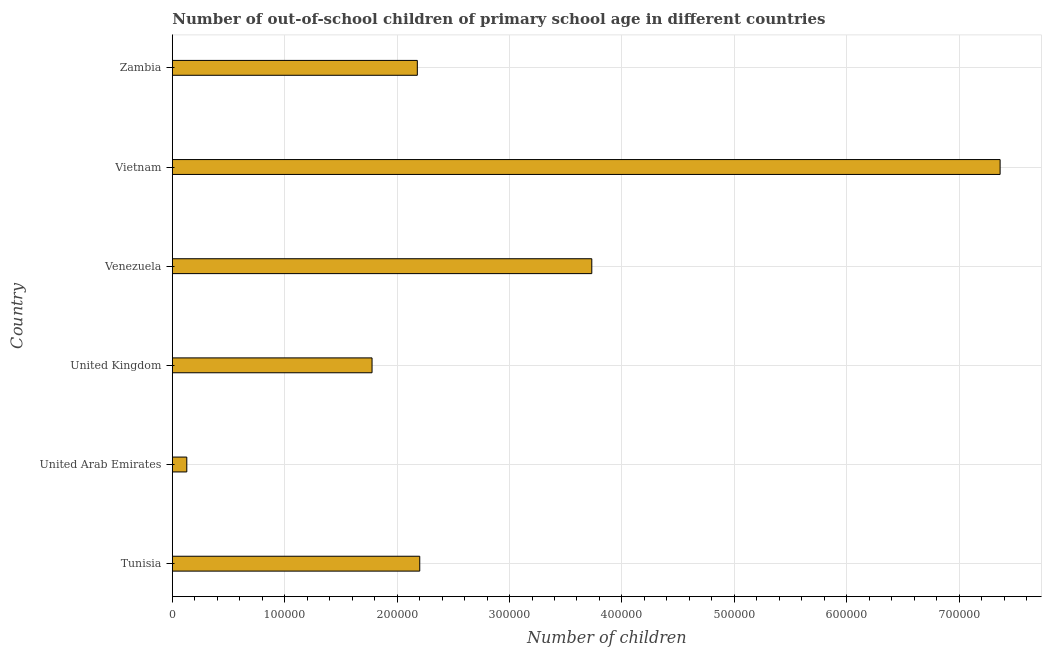Does the graph contain any zero values?
Give a very brief answer. No. Does the graph contain grids?
Your response must be concise. Yes. What is the title of the graph?
Your answer should be compact. Number of out-of-school children of primary school age in different countries. What is the label or title of the X-axis?
Your answer should be very brief. Number of children. What is the number of out-of-school children in Vietnam?
Provide a short and direct response. 7.36e+05. Across all countries, what is the maximum number of out-of-school children?
Make the answer very short. 7.36e+05. Across all countries, what is the minimum number of out-of-school children?
Your response must be concise. 1.29e+04. In which country was the number of out-of-school children maximum?
Offer a very short reply. Vietnam. In which country was the number of out-of-school children minimum?
Give a very brief answer. United Arab Emirates. What is the sum of the number of out-of-school children?
Offer a very short reply. 1.74e+06. What is the difference between the number of out-of-school children in Venezuela and Vietnam?
Offer a very short reply. -3.63e+05. What is the average number of out-of-school children per country?
Ensure brevity in your answer.  2.90e+05. What is the median number of out-of-school children?
Keep it short and to the point. 2.19e+05. In how many countries, is the number of out-of-school children greater than 120000 ?
Make the answer very short. 5. What is the ratio of the number of out-of-school children in Tunisia to that in Zambia?
Offer a terse response. 1.01. What is the difference between the highest and the second highest number of out-of-school children?
Your answer should be compact. 3.63e+05. Is the sum of the number of out-of-school children in United Arab Emirates and Vietnam greater than the maximum number of out-of-school children across all countries?
Provide a succinct answer. Yes. What is the difference between the highest and the lowest number of out-of-school children?
Provide a succinct answer. 7.24e+05. How many bars are there?
Make the answer very short. 6. How many countries are there in the graph?
Provide a succinct answer. 6. What is the difference between two consecutive major ticks on the X-axis?
Your answer should be compact. 1.00e+05. What is the Number of children in Tunisia?
Offer a very short reply. 2.20e+05. What is the Number of children of United Arab Emirates?
Offer a very short reply. 1.29e+04. What is the Number of children of United Kingdom?
Your answer should be compact. 1.78e+05. What is the Number of children in Venezuela?
Give a very brief answer. 3.73e+05. What is the Number of children of Vietnam?
Give a very brief answer. 7.36e+05. What is the Number of children in Zambia?
Give a very brief answer. 2.18e+05. What is the difference between the Number of children in Tunisia and United Arab Emirates?
Make the answer very short. 2.07e+05. What is the difference between the Number of children in Tunisia and United Kingdom?
Ensure brevity in your answer.  4.24e+04. What is the difference between the Number of children in Tunisia and Venezuela?
Your response must be concise. -1.53e+05. What is the difference between the Number of children in Tunisia and Vietnam?
Give a very brief answer. -5.16e+05. What is the difference between the Number of children in Tunisia and Zambia?
Make the answer very short. 2153. What is the difference between the Number of children in United Arab Emirates and United Kingdom?
Make the answer very short. -1.65e+05. What is the difference between the Number of children in United Arab Emirates and Venezuela?
Make the answer very short. -3.60e+05. What is the difference between the Number of children in United Arab Emirates and Vietnam?
Provide a short and direct response. -7.24e+05. What is the difference between the Number of children in United Arab Emirates and Zambia?
Provide a succinct answer. -2.05e+05. What is the difference between the Number of children in United Kingdom and Venezuela?
Provide a succinct answer. -1.96e+05. What is the difference between the Number of children in United Kingdom and Vietnam?
Your response must be concise. -5.59e+05. What is the difference between the Number of children in United Kingdom and Zambia?
Offer a terse response. -4.03e+04. What is the difference between the Number of children in Venezuela and Vietnam?
Keep it short and to the point. -3.63e+05. What is the difference between the Number of children in Venezuela and Zambia?
Ensure brevity in your answer.  1.55e+05. What is the difference between the Number of children in Vietnam and Zambia?
Ensure brevity in your answer.  5.19e+05. What is the ratio of the Number of children in Tunisia to that in United Arab Emirates?
Ensure brevity in your answer.  17.12. What is the ratio of the Number of children in Tunisia to that in United Kingdom?
Offer a very short reply. 1.24. What is the ratio of the Number of children in Tunisia to that in Venezuela?
Ensure brevity in your answer.  0.59. What is the ratio of the Number of children in Tunisia to that in Vietnam?
Make the answer very short. 0.3. What is the ratio of the Number of children in Tunisia to that in Zambia?
Your answer should be compact. 1.01. What is the ratio of the Number of children in United Arab Emirates to that in United Kingdom?
Make the answer very short. 0.07. What is the ratio of the Number of children in United Arab Emirates to that in Venezuela?
Your answer should be compact. 0.03. What is the ratio of the Number of children in United Arab Emirates to that in Vietnam?
Your response must be concise. 0.02. What is the ratio of the Number of children in United Arab Emirates to that in Zambia?
Your response must be concise. 0.06. What is the ratio of the Number of children in United Kingdom to that in Venezuela?
Provide a short and direct response. 0.48. What is the ratio of the Number of children in United Kingdom to that in Vietnam?
Keep it short and to the point. 0.24. What is the ratio of the Number of children in United Kingdom to that in Zambia?
Your answer should be very brief. 0.81. What is the ratio of the Number of children in Venezuela to that in Vietnam?
Give a very brief answer. 0.51. What is the ratio of the Number of children in Venezuela to that in Zambia?
Provide a succinct answer. 1.71. What is the ratio of the Number of children in Vietnam to that in Zambia?
Offer a terse response. 3.38. 